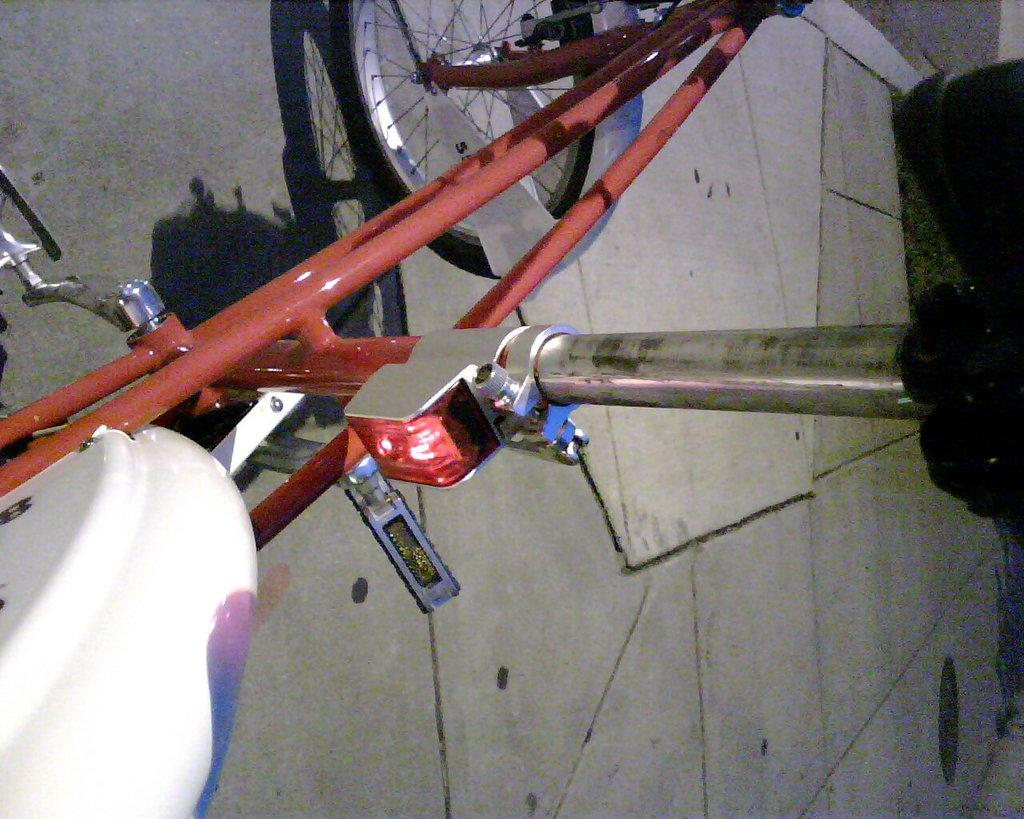What is the main object in the image? There is a bicycle in the image. Where is the bicycle located? The bicycle is on the floor. Can you see a snake slithering on the bicycle in the image? No, there is no snake present in the image. 